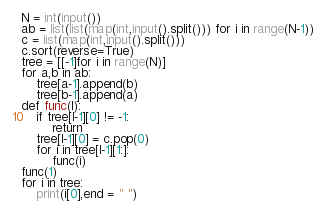Convert code to text. <code><loc_0><loc_0><loc_500><loc_500><_Python_>N = int(input())
ab = list(list(map(int,input().split())) for i in range(N-1))
c = list(map(int,input().split()))
c.sort(reverse=True)
tree = [[-1]for i in range(N)]
for a,b in ab:
    tree[a-1].append(b)
    tree[b-1].append(a)
def func(l):
    if tree[l-1][0] != -1:
        return
    tree[l-1][0] = c.pop(0)
    for i in tree[l-1][1:]:
        func(i)
func(1)
for i in tree:
    print(i[0],end = " ")</code> 